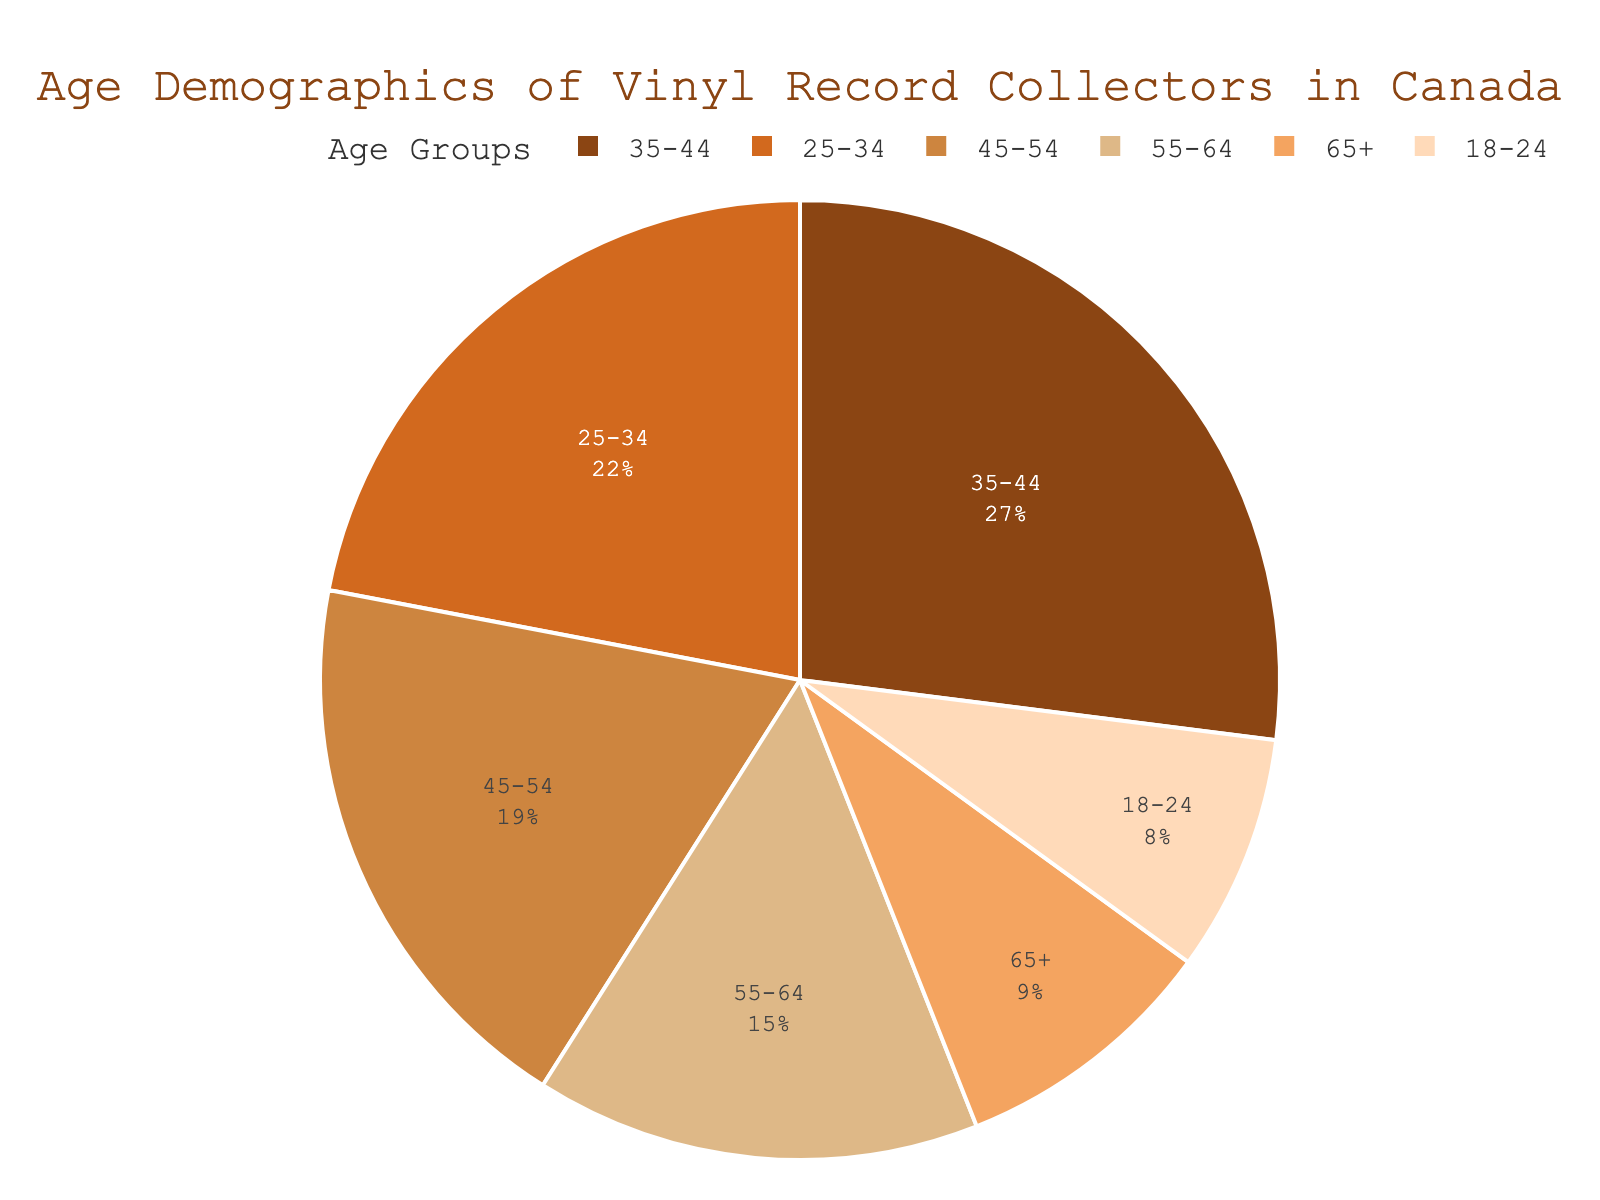What age group has the highest percentage of vinyl record collectors? The pie chart shows the highest percentage segment as having a larger visual area. The "35-44" group has the largest segment.
Answer: 35-44 How much larger is the percentage of the 35-44 age group compared to the 65+ age group? The pie chart indicates that the 35-44 age group is at 27% and the 65+ age group is at 9%. Subtracting 9 from 27 gives their difference.
Answer: 18% What is the total percentage of collectors aged between 25 and 44? The pie chart shows the percentages for groups 25-34 and 35-44 as 22% and 27%, respectively. Adding 22 and 27 gives the total for these age groups.
Answer: 49% Which age group is represented with a light brown color? By referring to the specific color segment in the pie chart, the color light brown visually corresponds to a particular age group.
Answer: 55-64 Is the percentage of vinyl collectors older than 45 (45-54, 55-64, 65+) greater than the percentage of collectors younger than 45 (18-24, 25-34, 35-44)? To determine this, sum the percentages of age groups older than 45 (19% + 15% + 9%) which equals 43%, and sum percentages of younger age groups (8% + 22% + 27%) which equals 57%. Compare the two sums.
Answer: No Which age group is the second most populous among vinyl record collectors? By visually inspecting the size of the pie segments for each age group, the segment for "25-34" is the second largest after "35-44".
Answer: 25-34 Do the age groups 45-54 and 55-64 together represent a greater percentage than the 35-44 group? Add the percentages of the 45-54 and 55-64 groups (19% + 15%) to compare with the 35-44 group (27%). The sum is 34%, which is indeed greater than 27%.
Answer: Yes What's the total percentage of vinyl collectors below 25 and above 65? Sum the percentages for the age groups 18-24 (8%) and 65+ (9%). The total is 8% + 9% = 17%.
Answer: 17% Between which two age groups do we see the smallest difference in percentage? Subtract the percentages of adjacent age groups: 35-44 (27%) and 45-54 (19%) difference is 8%, 45-54 and 55-64 difference is 4%, and so on. The smallest difference is between 45-54 and 55-64.
Answer: 45-54 and 55-64 Which age group has a percentage closer to that of the 65+ group, the 18-24 group or the 55-64 group? Comparing the absolute difference between the percentages of the 65+ group (9%) with the 18-24 (8%) and the 55-64 (15%) groups, respectively, shows that 18-24 is closer (1% difference).
Answer: 18-24 